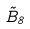<formula> <loc_0><loc_0><loc_500><loc_500>\tilde { B } _ { 8 }</formula> 